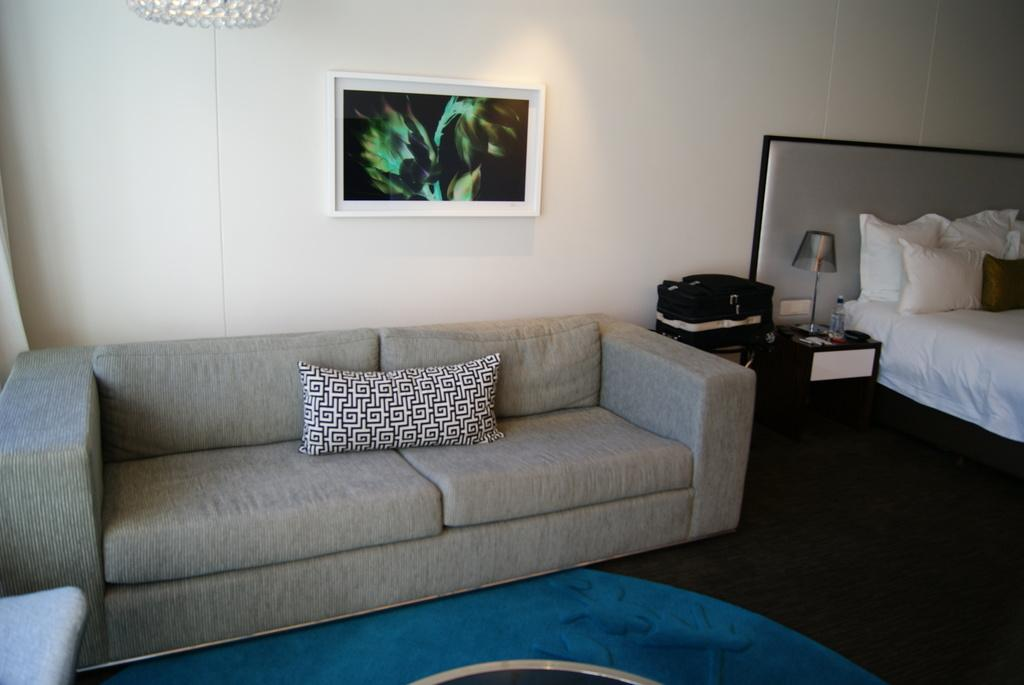What type of furniture is on the floor in the image? There is a sofa set on the floor. What other piece of furniture can be seen in the image? There is a cot in the image. What is placed on the cot? There are pillows on the cot. What is visible on the wall in the image? There is a photo frame on the wall. What is the background of the image? The background of the image includes a wall. What type of hydrant can be seen in the image? There is no hydrant present in the image. What type of pan is visible on the cot? There is no pan visible in the image; the cot has pillows on it. 